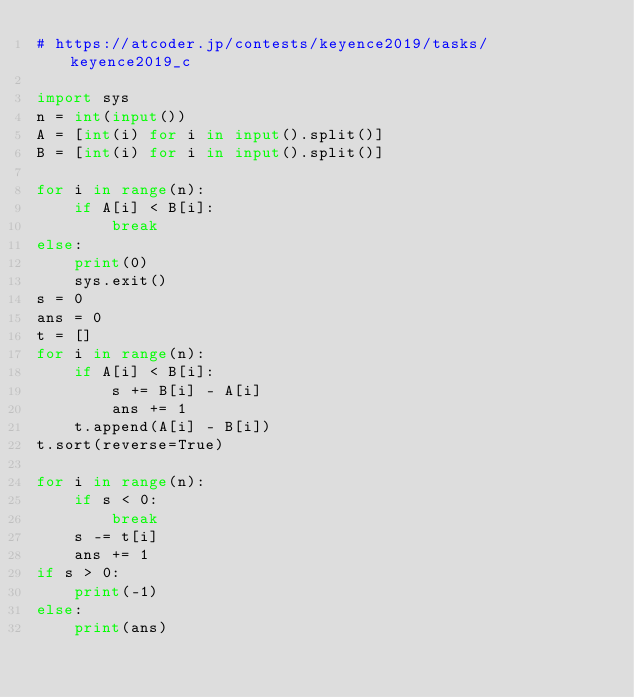<code> <loc_0><loc_0><loc_500><loc_500><_Python_># https://atcoder.jp/contests/keyence2019/tasks/keyence2019_c

import sys
n = int(input())
A = [int(i) for i in input().split()]
B = [int(i) for i in input().split()]

for i in range(n):
    if A[i] < B[i]:
        break
else:
    print(0)
    sys.exit()
s = 0
ans = 0
t = []
for i in range(n):
    if A[i] < B[i]:
        s += B[i] - A[i]
        ans += 1
    t.append(A[i] - B[i])
t.sort(reverse=True)

for i in range(n):
    if s < 0:
        break
    s -= t[i]
    ans += 1
if s > 0:
    print(-1)
else:
    print(ans)
</code> 